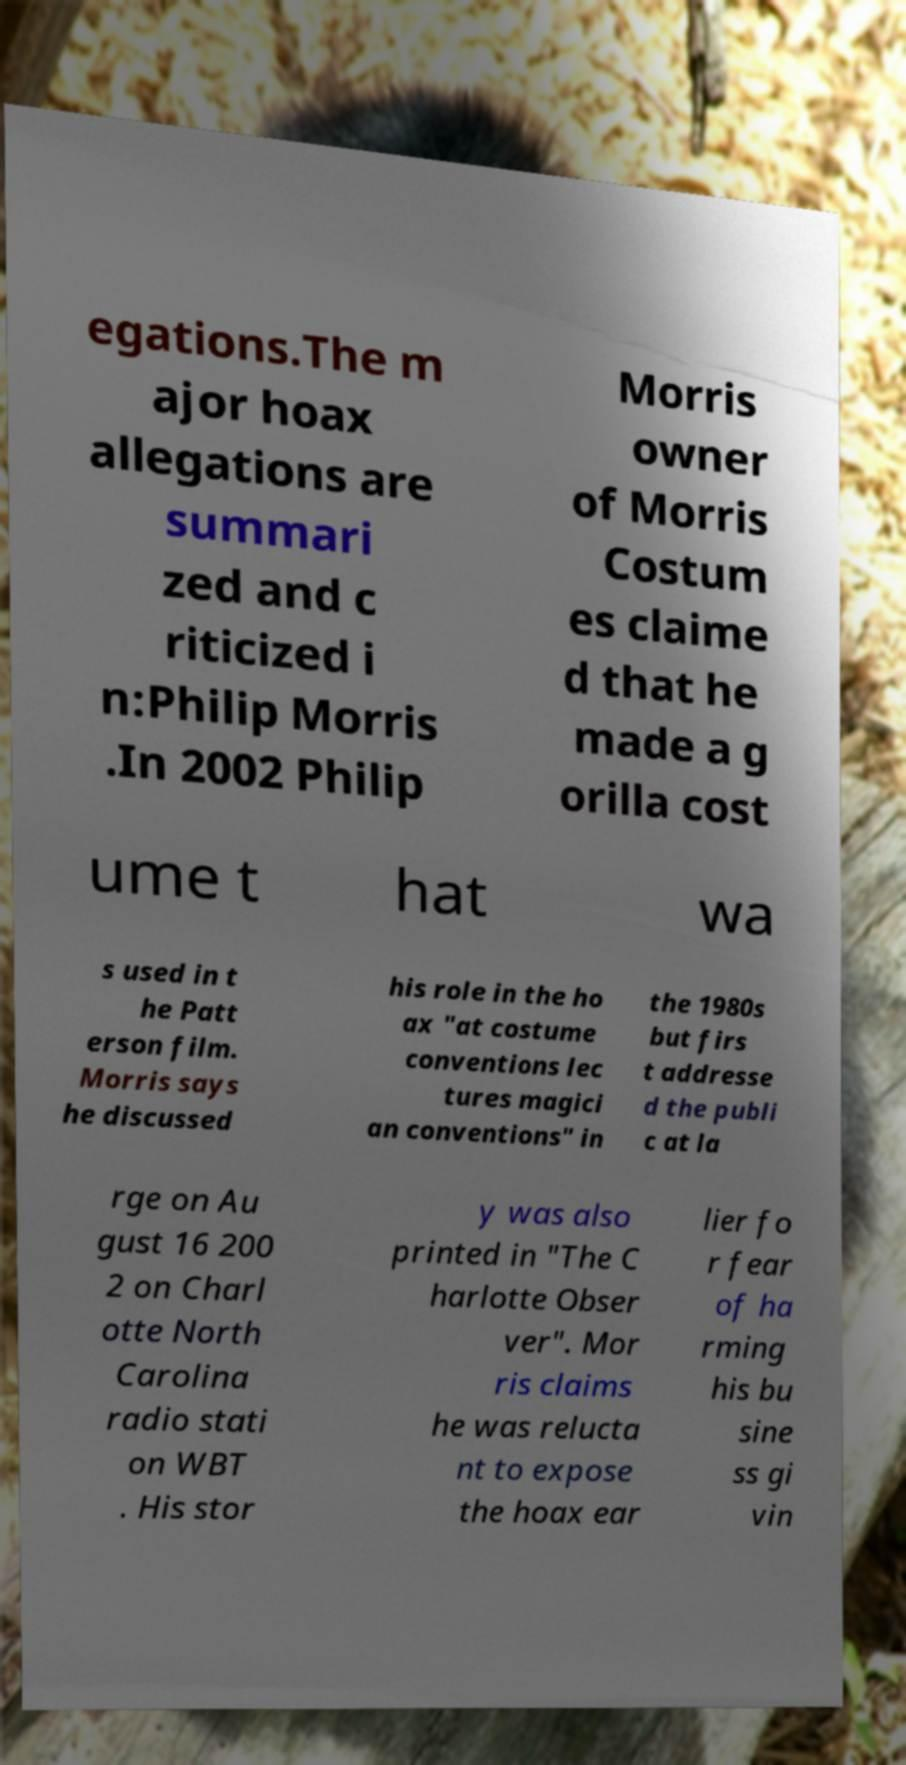Can you accurately transcribe the text from the provided image for me? egations.The m ajor hoax allegations are summari zed and c riticized i n:Philip Morris .In 2002 Philip Morris owner of Morris Costum es claime d that he made a g orilla cost ume t hat wa s used in t he Patt erson film. Morris says he discussed his role in the ho ax "at costume conventions lec tures magici an conventions" in the 1980s but firs t addresse d the publi c at la rge on Au gust 16 200 2 on Charl otte North Carolina radio stati on WBT . His stor y was also printed in "The C harlotte Obser ver". Mor ris claims he was relucta nt to expose the hoax ear lier fo r fear of ha rming his bu sine ss gi vin 